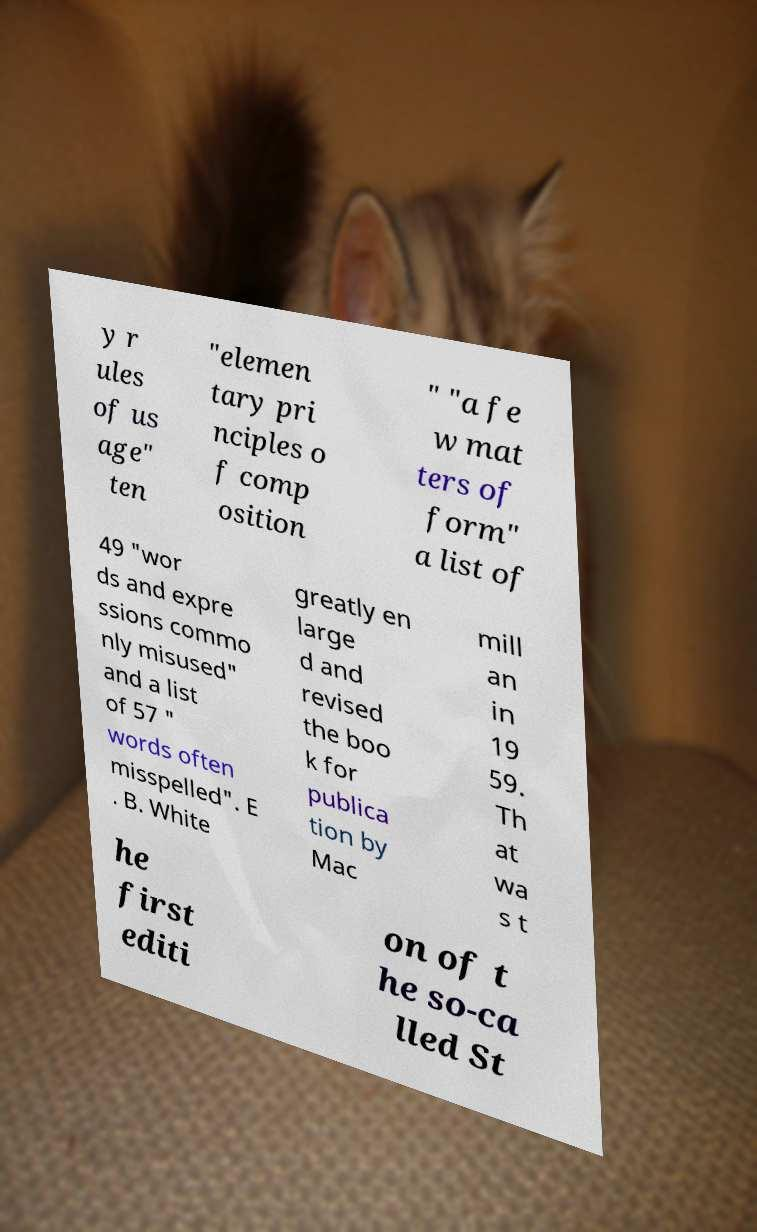Please identify and transcribe the text found in this image. y r ules of us age" ten "elemen tary pri nciples o f comp osition " "a fe w mat ters of form" a list of 49 "wor ds and expre ssions commo nly misused" and a list of 57 " words often misspelled". E . B. White greatly en large d and revised the boo k for publica tion by Mac mill an in 19 59. Th at wa s t he first editi on of t he so-ca lled St 